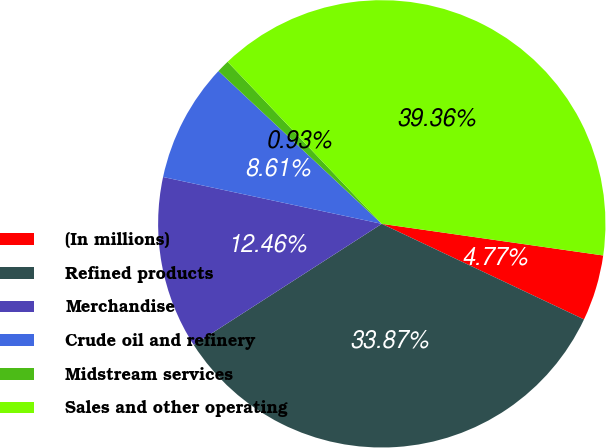Convert chart. <chart><loc_0><loc_0><loc_500><loc_500><pie_chart><fcel>(In millions)<fcel>Refined products<fcel>Merchandise<fcel>Crude oil and refinery<fcel>Midstream services<fcel>Sales and other operating<nl><fcel>4.77%<fcel>33.87%<fcel>12.46%<fcel>8.61%<fcel>0.93%<fcel>39.36%<nl></chart> 